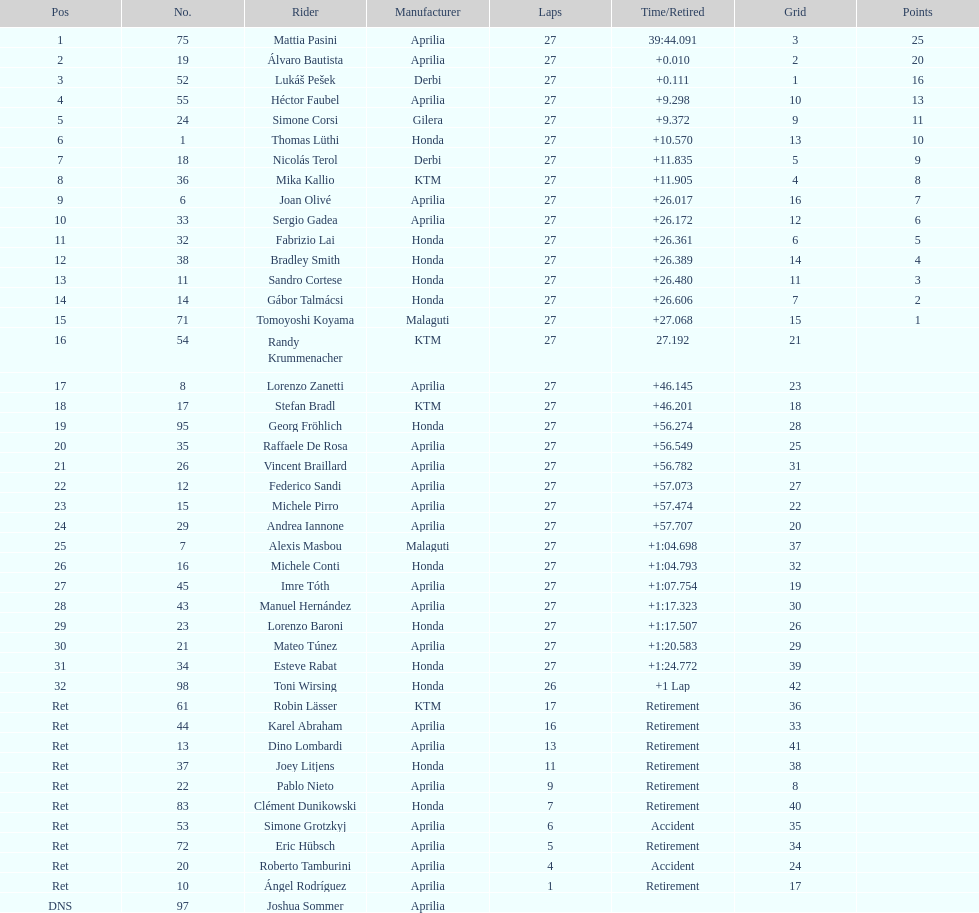Who placed higher, bradl or gadea? Sergio Gadea. Could you help me parse every detail presented in this table? {'header': ['Pos', 'No.', 'Rider', 'Manufacturer', 'Laps', 'Time/Retired', 'Grid', 'Points'], 'rows': [['1', '75', 'Mattia Pasini', 'Aprilia', '27', '39:44.091', '3', '25'], ['2', '19', 'Álvaro Bautista', 'Aprilia', '27', '+0.010', '2', '20'], ['3', '52', 'Lukáš Pešek', 'Derbi', '27', '+0.111', '1', '16'], ['4', '55', 'Héctor Faubel', 'Aprilia', '27', '+9.298', '10', '13'], ['5', '24', 'Simone Corsi', 'Gilera', '27', '+9.372', '9', '11'], ['6', '1', 'Thomas Lüthi', 'Honda', '27', '+10.570', '13', '10'], ['7', '18', 'Nicolás Terol', 'Derbi', '27', '+11.835', '5', '9'], ['8', '36', 'Mika Kallio', 'KTM', '27', '+11.905', '4', '8'], ['9', '6', 'Joan Olivé', 'Aprilia', '27', '+26.017', '16', '7'], ['10', '33', 'Sergio Gadea', 'Aprilia', '27', '+26.172', '12', '6'], ['11', '32', 'Fabrizio Lai', 'Honda', '27', '+26.361', '6', '5'], ['12', '38', 'Bradley Smith', 'Honda', '27', '+26.389', '14', '4'], ['13', '11', 'Sandro Cortese', 'Honda', '27', '+26.480', '11', '3'], ['14', '14', 'Gábor Talmácsi', 'Honda', '27', '+26.606', '7', '2'], ['15', '71', 'Tomoyoshi Koyama', 'Malaguti', '27', '+27.068', '15', '1'], ['16', '54', 'Randy Krummenacher', 'KTM', '27', '27.192', '21', ''], ['17', '8', 'Lorenzo Zanetti', 'Aprilia', '27', '+46.145', '23', ''], ['18', '17', 'Stefan Bradl', 'KTM', '27', '+46.201', '18', ''], ['19', '95', 'Georg Fröhlich', 'Honda', '27', '+56.274', '28', ''], ['20', '35', 'Raffaele De Rosa', 'Aprilia', '27', '+56.549', '25', ''], ['21', '26', 'Vincent Braillard', 'Aprilia', '27', '+56.782', '31', ''], ['22', '12', 'Federico Sandi', 'Aprilia', '27', '+57.073', '27', ''], ['23', '15', 'Michele Pirro', 'Aprilia', '27', '+57.474', '22', ''], ['24', '29', 'Andrea Iannone', 'Aprilia', '27', '+57.707', '20', ''], ['25', '7', 'Alexis Masbou', 'Malaguti', '27', '+1:04.698', '37', ''], ['26', '16', 'Michele Conti', 'Honda', '27', '+1:04.793', '32', ''], ['27', '45', 'Imre Tóth', 'Aprilia', '27', '+1:07.754', '19', ''], ['28', '43', 'Manuel Hernández', 'Aprilia', '27', '+1:17.323', '30', ''], ['29', '23', 'Lorenzo Baroni', 'Honda', '27', '+1:17.507', '26', ''], ['30', '21', 'Mateo Túnez', 'Aprilia', '27', '+1:20.583', '29', ''], ['31', '34', 'Esteve Rabat', 'Honda', '27', '+1:24.772', '39', ''], ['32', '98', 'Toni Wirsing', 'Honda', '26', '+1 Lap', '42', ''], ['Ret', '61', 'Robin Lässer', 'KTM', '17', 'Retirement', '36', ''], ['Ret', '44', 'Karel Abraham', 'Aprilia', '16', 'Retirement', '33', ''], ['Ret', '13', 'Dino Lombardi', 'Aprilia', '13', 'Retirement', '41', ''], ['Ret', '37', 'Joey Litjens', 'Honda', '11', 'Retirement', '38', ''], ['Ret', '22', 'Pablo Nieto', 'Aprilia', '9', 'Retirement', '8', ''], ['Ret', '83', 'Clément Dunikowski', 'Honda', '7', 'Retirement', '40', ''], ['Ret', '53', 'Simone Grotzkyj', 'Aprilia', '6', 'Accident', '35', ''], ['Ret', '72', 'Eric Hübsch', 'Aprilia', '5', 'Retirement', '34', ''], ['Ret', '20', 'Roberto Tamburini', 'Aprilia', '4', 'Accident', '24', ''], ['Ret', '10', 'Ángel Rodríguez', 'Aprilia', '1', 'Retirement', '17', ''], ['DNS', '97', 'Joshua Sommer', 'Aprilia', '', '', '', '']]} 